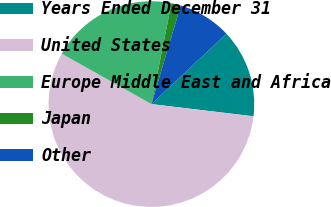Convert chart to OTSL. <chart><loc_0><loc_0><loc_500><loc_500><pie_chart><fcel>Years Ended December 31<fcel>United States<fcel>Europe Middle East and Africa<fcel>Japan<fcel>Other<nl><fcel>13.89%<fcel>56.25%<fcel>19.97%<fcel>1.47%<fcel>8.41%<nl></chart> 